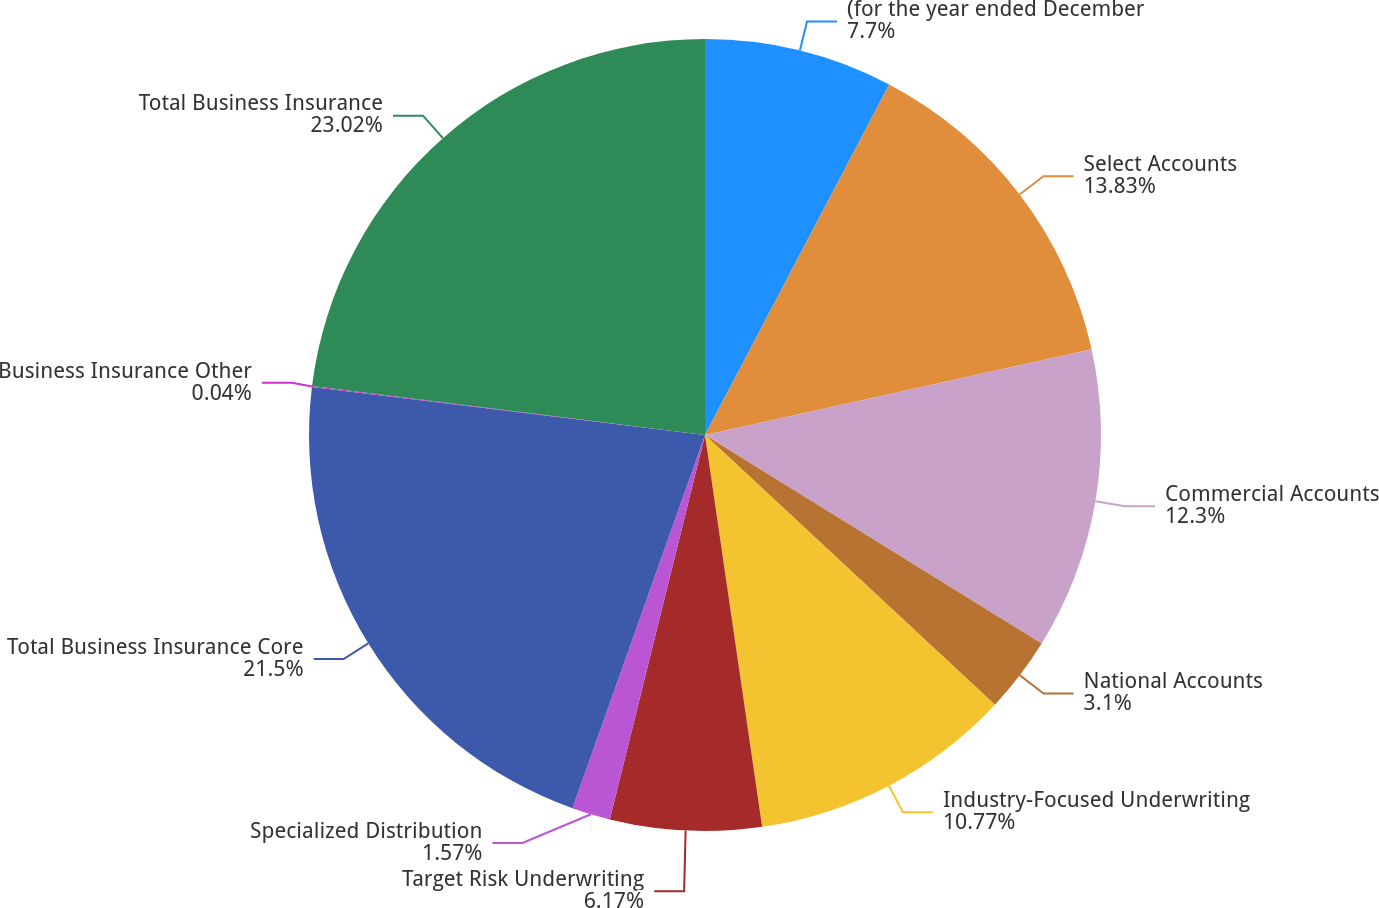Convert chart to OTSL. <chart><loc_0><loc_0><loc_500><loc_500><pie_chart><fcel>(for the year ended December<fcel>Select Accounts<fcel>Commercial Accounts<fcel>National Accounts<fcel>Industry-Focused Underwriting<fcel>Target Risk Underwriting<fcel>Specialized Distribution<fcel>Total Business Insurance Core<fcel>Business Insurance Other<fcel>Total Business Insurance<nl><fcel>7.7%<fcel>13.83%<fcel>12.3%<fcel>3.1%<fcel>10.77%<fcel>6.17%<fcel>1.57%<fcel>21.5%<fcel>0.04%<fcel>23.03%<nl></chart> 